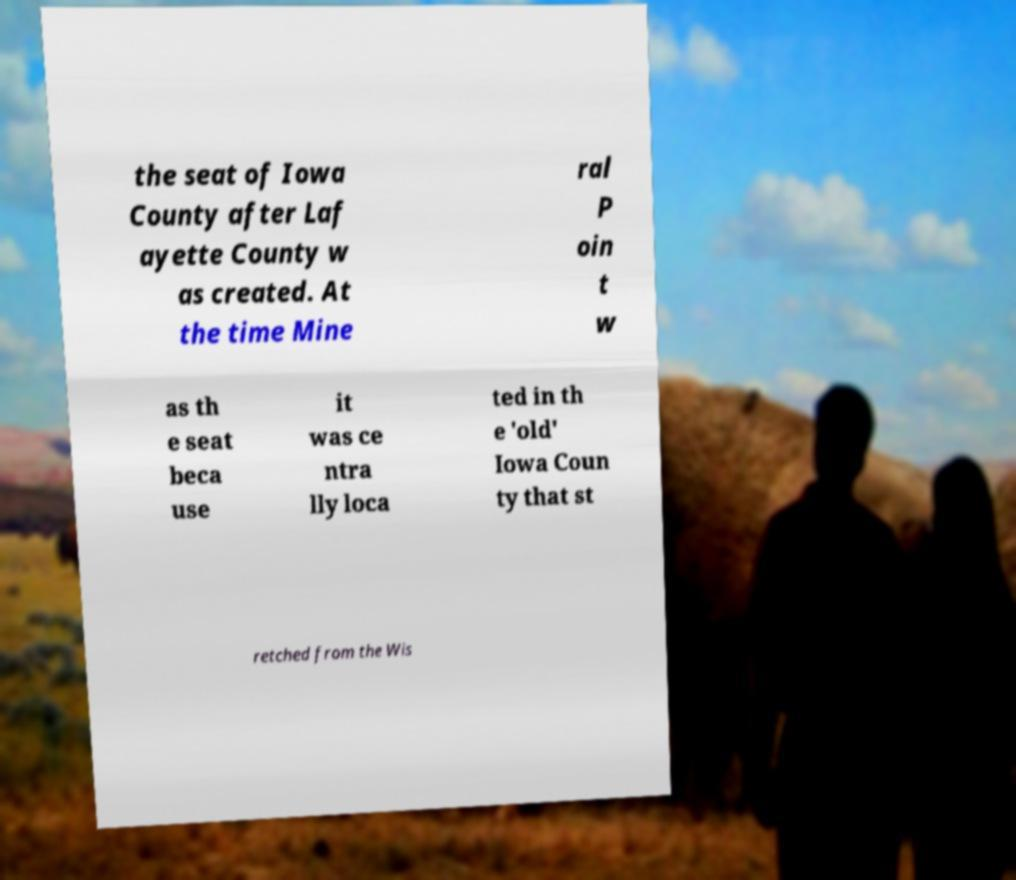Please identify and transcribe the text found in this image. the seat of Iowa County after Laf ayette County w as created. At the time Mine ral P oin t w as th e seat beca use it was ce ntra lly loca ted in th e 'old' Iowa Coun ty that st retched from the Wis 